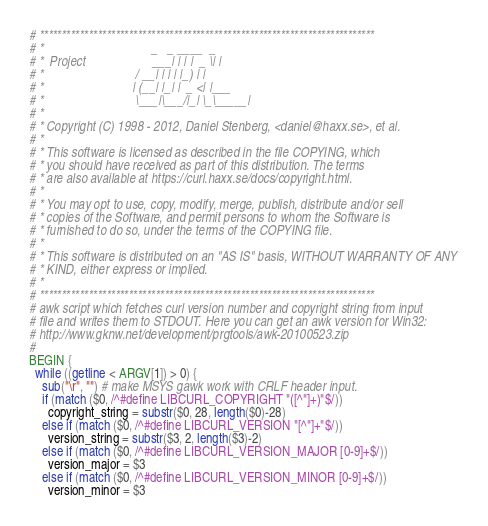<code> <loc_0><loc_0><loc_500><loc_500><_Awk_># ***************************************************************************
# *                                  _   _ ____  _
# *  Project                     ___| | | |  _ \| |
# *                             / __| | | | |_) | |
# *                            | (__| |_| |  _ <| |___
# *                             \___|\___/|_| \_\_____|
# *
# * Copyright (C) 1998 - 2012, Daniel Stenberg, <daniel@haxx.se>, et al.
# *
# * This software is licensed as described in the file COPYING, which
# * you should have received as part of this distribution. The terms
# * are also available at https://curl.haxx.se/docs/copyright.html.
# *
# * You may opt to use, copy, modify, merge, publish, distribute and/or sell
# * copies of the Software, and permit persons to whom the Software is
# * furnished to do so, under the terms of the COPYING file.
# *
# * This software is distributed on an "AS IS" basis, WITHOUT WARRANTY OF ANY
# * KIND, either express or implied.
# *
# ***************************************************************************
# awk script which fetches curl version number and copyright string from input
# file and writes them to STDOUT. Here you can get an awk version for Win32:
# http://www.gknw.net/development/prgtools/awk-20100523.zip
#
BEGIN {
  while ((getline < ARGV[1]) > 0) {
    sub("\r", "") # make MSYS gawk work with CRLF header input.
    if (match ($0, /^#define LIBCURL_COPYRIGHT "([^"]+)"$/))
      copyright_string = substr($0, 28, length($0)-28)
    else if (match ($0, /^#define LIBCURL_VERSION "[^"]+"$/))
      version_string = substr($3, 2, length($3)-2)
    else if (match ($0, /^#define LIBCURL_VERSION_MAJOR [0-9]+$/))
      version_major = $3
    else if (match ($0, /^#define LIBCURL_VERSION_MINOR [0-9]+$/))
      version_minor = $3</code> 